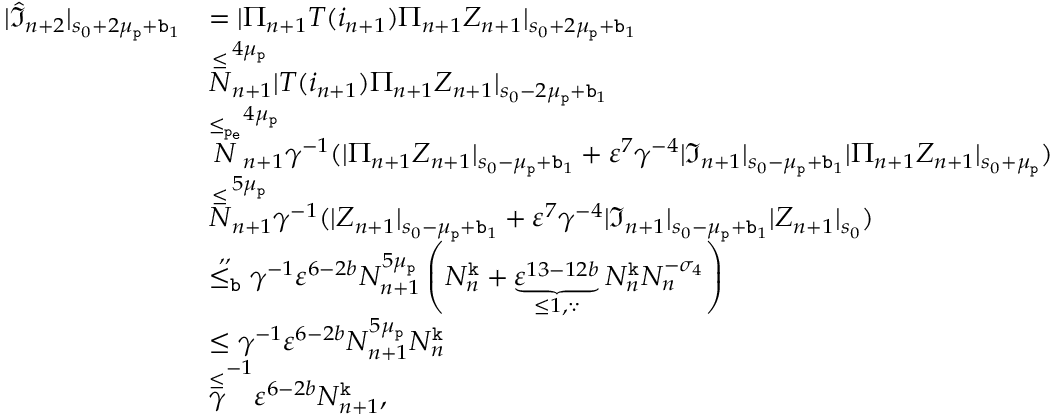Convert formula to latex. <formula><loc_0><loc_0><loc_500><loc_500>\begin{array} { r l } { | \widehat { \mathfrak { I } } _ { n + 2 } | _ { s _ { 0 } + 2 \mu _ { p } + b _ { 1 } } } & { = | \Pi _ { n + 1 } T ( i _ { n + 1 } ) \Pi _ { n + 1 } Z _ { n + 1 } | _ { s _ { 0 } + 2 \mu _ { p } + b _ { 1 } } } \\ & { \overset { \leq } { N } _ { n + 1 } ^ { 4 \mu _ { p } } | T ( i _ { n + 1 } ) \Pi _ { n + 1 } Z _ { n + 1 } | _ { s _ { 0 } - 2 \mu _ { p } + b _ { 1 } } } \\ & { \overset { \leq _ { p _ { e } } } N _ { n + 1 } ^ { 4 \mu _ { p } } \gamma ^ { - 1 } ( | \Pi _ { n + 1 } Z _ { n + 1 } | _ { s _ { 0 } - \mu _ { p } + b _ { 1 } } + \varepsilon ^ { 7 } \gamma ^ { - 4 } | \mathfrak { I } _ { n + 1 } | _ { s _ { 0 } - \mu _ { p } + b _ { 1 } } | \Pi _ { n + 1 } Z _ { n + 1 } | _ { s _ { 0 } + \mu _ { p } } ) } \\ & { \overset { \leq } { N } _ { n + 1 } ^ { 5 \mu _ { p } } \gamma ^ { - 1 } ( | Z _ { n + 1 } | _ { s _ { 0 } - \mu _ { p } + b _ { 1 } } + \varepsilon ^ { 7 } \gamma ^ { - 4 } | \mathfrak { I } _ { n + 1 } | _ { s _ { 0 } - \mu _ { p } + b _ { 1 } } | Z _ { n + 1 } | _ { s _ { 0 } } ) } \\ & { \overset { , , } { \leq _ { b } } \gamma ^ { - 1 } \varepsilon ^ { 6 - 2 b } N _ { n + 1 } ^ { 5 \mu _ { p } } \left ( N _ { n } ^ { k } + \underbrace { \varepsilon ^ { 1 3 - 1 2 b } } _ { \leq 1 , \because } N _ { n } ^ { k } N _ { n } ^ { - \sigma _ { 4 } } \right ) } \\ & { \leq \gamma ^ { - 1 } \varepsilon ^ { 6 - 2 b } N _ { n + 1 } ^ { 5 \mu _ { p } } N _ { n } ^ { k } } \\ & { \overset { \leq } { \gamma } ^ { - 1 } \varepsilon ^ { 6 - 2 b } N _ { n + 1 } ^ { k } , } \end{array}</formula> 